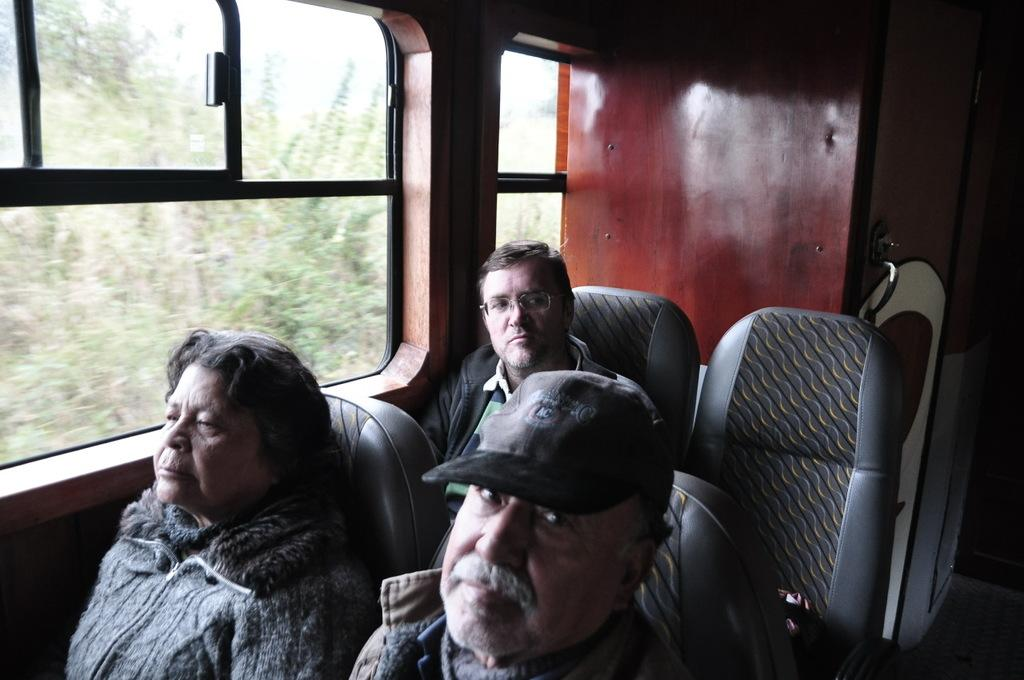What type of setting is depicted in the image? The image is an inside view of a vehicle. How many people are present in the image? There are three people sitting on chairs in the image. What can be seen in the background of the image? Trees are visible in the background of the image. What year is the drain featured in the image? There is no drain present in the image, so it is not possible to determine the year it might be featured. 